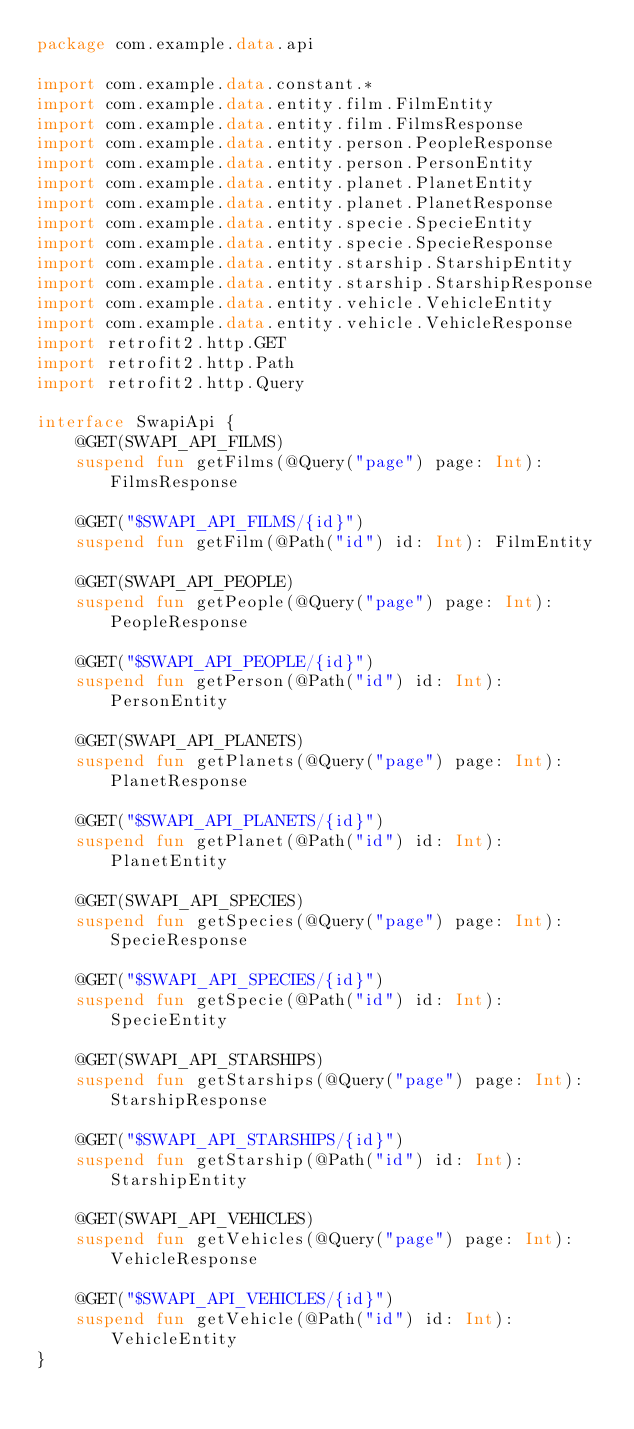Convert code to text. <code><loc_0><loc_0><loc_500><loc_500><_Kotlin_>package com.example.data.api

import com.example.data.constant.*
import com.example.data.entity.film.FilmEntity
import com.example.data.entity.film.FilmsResponse
import com.example.data.entity.person.PeopleResponse
import com.example.data.entity.person.PersonEntity
import com.example.data.entity.planet.PlanetEntity
import com.example.data.entity.planet.PlanetResponse
import com.example.data.entity.specie.SpecieEntity
import com.example.data.entity.specie.SpecieResponse
import com.example.data.entity.starship.StarshipEntity
import com.example.data.entity.starship.StarshipResponse
import com.example.data.entity.vehicle.VehicleEntity
import com.example.data.entity.vehicle.VehicleResponse
import retrofit2.http.GET
import retrofit2.http.Path
import retrofit2.http.Query

interface SwapiApi {
    @GET(SWAPI_API_FILMS)
    suspend fun getFilms(@Query("page") page: Int): FilmsResponse

    @GET("$SWAPI_API_FILMS/{id}")
    suspend fun getFilm(@Path("id") id: Int): FilmEntity

    @GET(SWAPI_API_PEOPLE)
    suspend fun getPeople(@Query("page") page: Int): PeopleResponse

    @GET("$SWAPI_API_PEOPLE/{id}")
    suspend fun getPerson(@Path("id") id: Int): PersonEntity

    @GET(SWAPI_API_PLANETS)
    suspend fun getPlanets(@Query("page") page: Int): PlanetResponse

    @GET("$SWAPI_API_PLANETS/{id}")
    suspend fun getPlanet(@Path("id") id: Int): PlanetEntity

    @GET(SWAPI_API_SPECIES)
    suspend fun getSpecies(@Query("page") page: Int): SpecieResponse

    @GET("$SWAPI_API_SPECIES/{id}")
    suspend fun getSpecie(@Path("id") id: Int): SpecieEntity

    @GET(SWAPI_API_STARSHIPS)
    suspend fun getStarships(@Query("page") page: Int): StarshipResponse

    @GET("$SWAPI_API_STARSHIPS/{id}")
    suspend fun getStarship(@Path("id") id: Int): StarshipEntity

    @GET(SWAPI_API_VEHICLES)
    suspend fun getVehicles(@Query("page") page: Int): VehicleResponse

    @GET("$SWAPI_API_VEHICLES/{id}")
    suspend fun getVehicle(@Path("id") id: Int): VehicleEntity
}</code> 